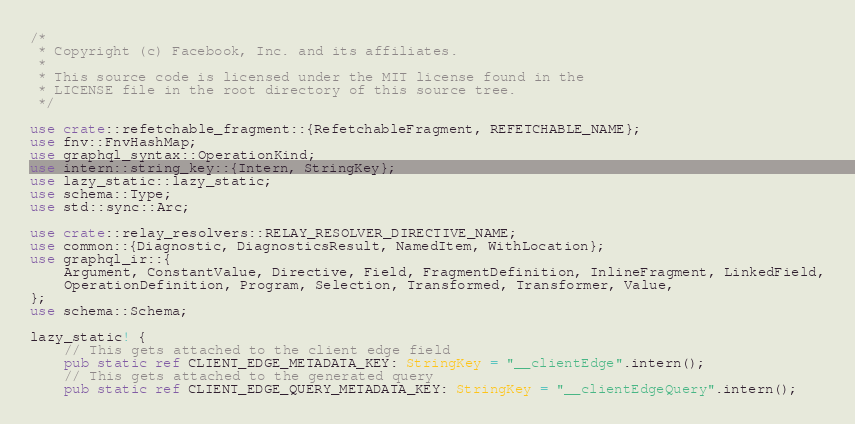<code> <loc_0><loc_0><loc_500><loc_500><_Rust_>/*
 * Copyright (c) Facebook, Inc. and its affiliates.
 *
 * This source code is licensed under the MIT license found in the
 * LICENSE file in the root directory of this source tree.
 */

use crate::refetchable_fragment::{RefetchableFragment, REFETCHABLE_NAME};
use fnv::FnvHashMap;
use graphql_syntax::OperationKind;
use intern::string_key::{Intern, StringKey};
use lazy_static::lazy_static;
use schema::Type;
use std::sync::Arc;

use crate::relay_resolvers::RELAY_RESOLVER_DIRECTIVE_NAME;
use common::{Diagnostic, DiagnosticsResult, NamedItem, WithLocation};
use graphql_ir::{
    Argument, ConstantValue, Directive, Field, FragmentDefinition, InlineFragment, LinkedField,
    OperationDefinition, Program, Selection, Transformed, Transformer, Value,
};
use schema::Schema;

lazy_static! {
    // This gets attached to the client edge field
    pub static ref CLIENT_EDGE_METADATA_KEY: StringKey = "__clientEdge".intern();
    // This gets attached to the generated query
    pub static ref CLIENT_EDGE_QUERY_METADATA_KEY: StringKey = "__clientEdgeQuery".intern();</code> 